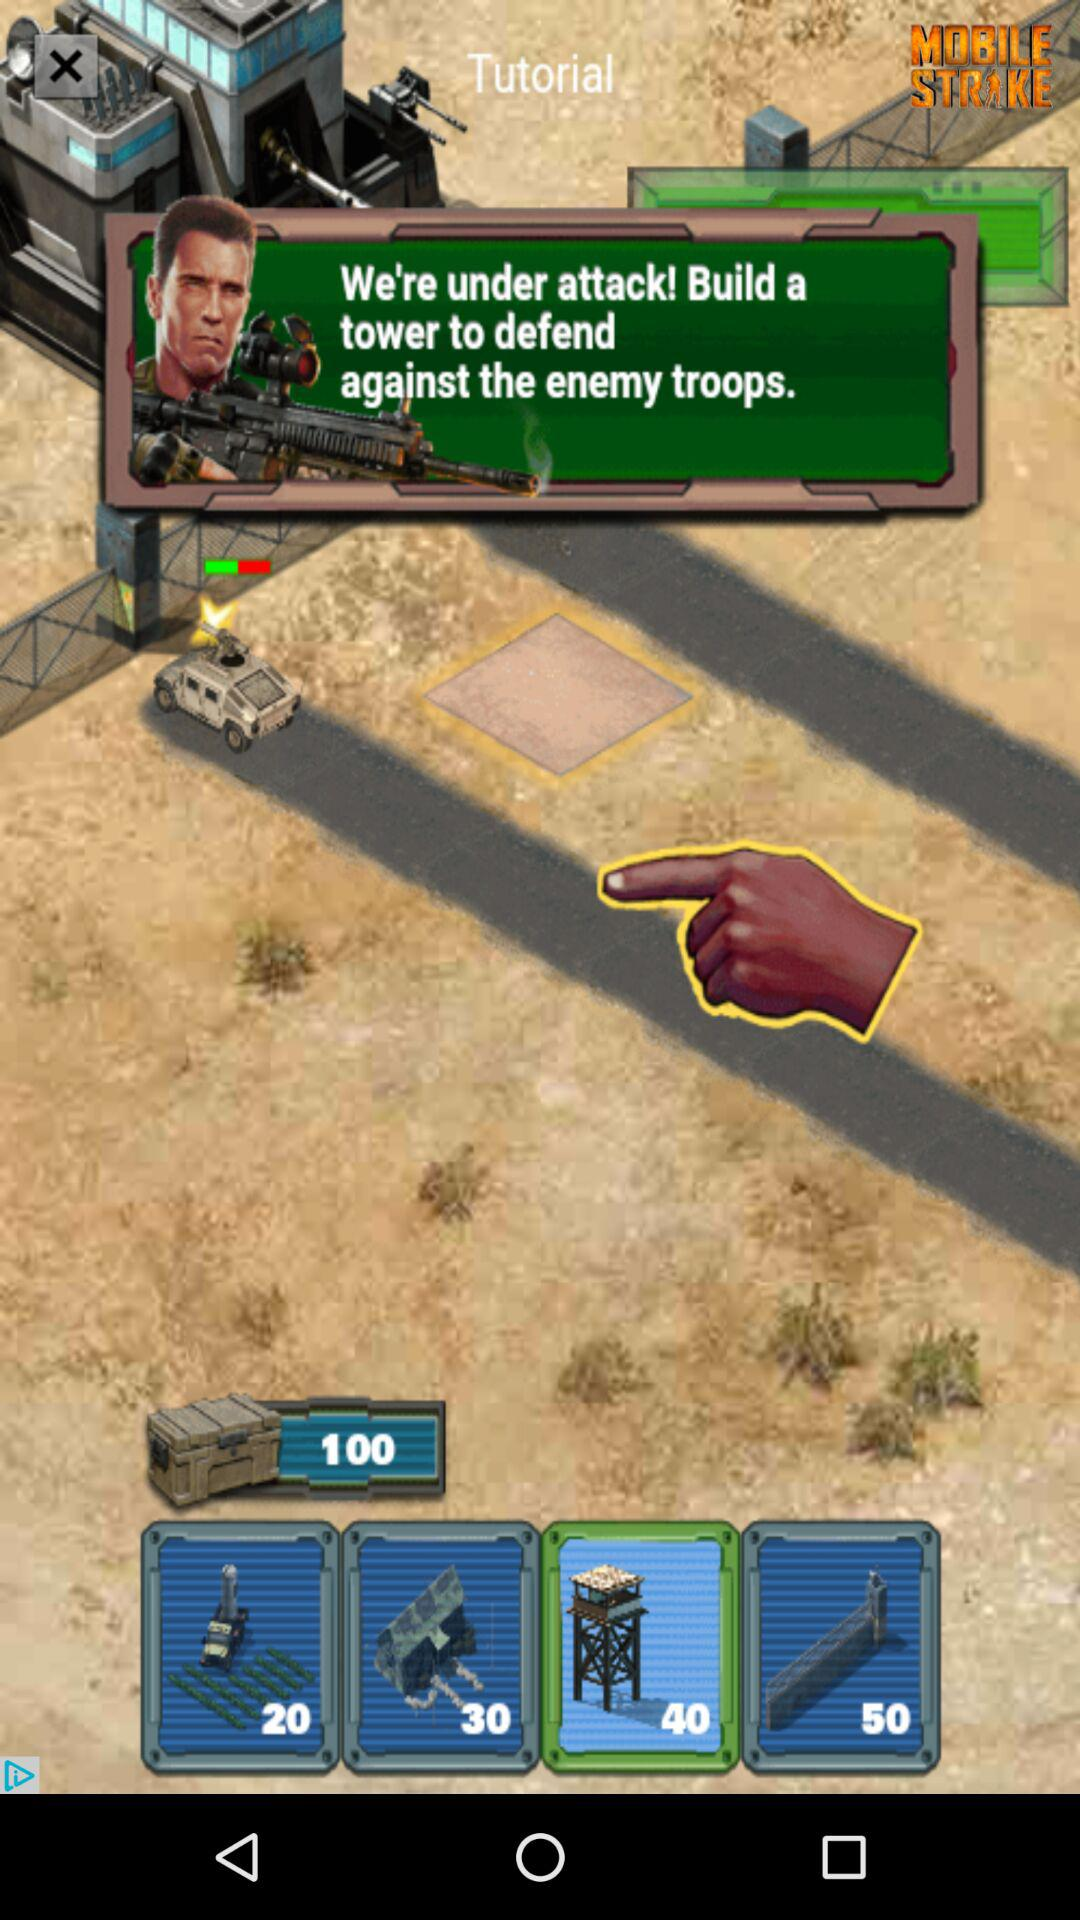How many more points are required to build a tower than a military vehicle?
Answer the question using a single word or phrase. 20 